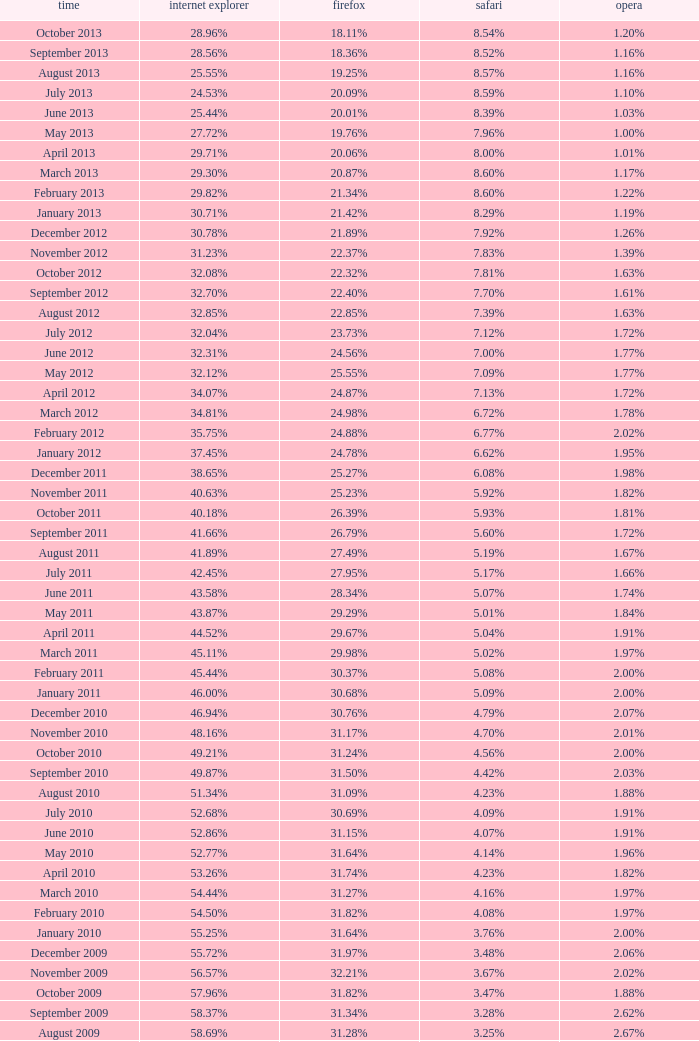Give me the full table as a dictionary. {'header': ['time', 'internet explorer', 'firefox', 'safari', 'opera'], 'rows': [['October 2013', '28.96%', '18.11%', '8.54%', '1.20%'], ['September 2013', '28.56%', '18.36%', '8.52%', '1.16%'], ['August 2013', '25.55%', '19.25%', '8.57%', '1.16%'], ['July 2013', '24.53%', '20.09%', '8.59%', '1.10%'], ['June 2013', '25.44%', '20.01%', '8.39%', '1.03%'], ['May 2013', '27.72%', '19.76%', '7.96%', '1.00%'], ['April 2013', '29.71%', '20.06%', '8.00%', '1.01%'], ['March 2013', '29.30%', '20.87%', '8.60%', '1.17%'], ['February 2013', '29.82%', '21.34%', '8.60%', '1.22%'], ['January 2013', '30.71%', '21.42%', '8.29%', '1.19%'], ['December 2012', '30.78%', '21.89%', '7.92%', '1.26%'], ['November 2012', '31.23%', '22.37%', '7.83%', '1.39%'], ['October 2012', '32.08%', '22.32%', '7.81%', '1.63%'], ['September 2012', '32.70%', '22.40%', '7.70%', '1.61%'], ['August 2012', '32.85%', '22.85%', '7.39%', '1.63%'], ['July 2012', '32.04%', '23.73%', '7.12%', '1.72%'], ['June 2012', '32.31%', '24.56%', '7.00%', '1.77%'], ['May 2012', '32.12%', '25.55%', '7.09%', '1.77%'], ['April 2012', '34.07%', '24.87%', '7.13%', '1.72%'], ['March 2012', '34.81%', '24.98%', '6.72%', '1.78%'], ['February 2012', '35.75%', '24.88%', '6.77%', '2.02%'], ['January 2012', '37.45%', '24.78%', '6.62%', '1.95%'], ['December 2011', '38.65%', '25.27%', '6.08%', '1.98%'], ['November 2011', '40.63%', '25.23%', '5.92%', '1.82%'], ['October 2011', '40.18%', '26.39%', '5.93%', '1.81%'], ['September 2011', '41.66%', '26.79%', '5.60%', '1.72%'], ['August 2011', '41.89%', '27.49%', '5.19%', '1.67%'], ['July 2011', '42.45%', '27.95%', '5.17%', '1.66%'], ['June 2011', '43.58%', '28.34%', '5.07%', '1.74%'], ['May 2011', '43.87%', '29.29%', '5.01%', '1.84%'], ['April 2011', '44.52%', '29.67%', '5.04%', '1.91%'], ['March 2011', '45.11%', '29.98%', '5.02%', '1.97%'], ['February 2011', '45.44%', '30.37%', '5.08%', '2.00%'], ['January 2011', '46.00%', '30.68%', '5.09%', '2.00%'], ['December 2010', '46.94%', '30.76%', '4.79%', '2.07%'], ['November 2010', '48.16%', '31.17%', '4.70%', '2.01%'], ['October 2010', '49.21%', '31.24%', '4.56%', '2.00%'], ['September 2010', '49.87%', '31.50%', '4.42%', '2.03%'], ['August 2010', '51.34%', '31.09%', '4.23%', '1.88%'], ['July 2010', '52.68%', '30.69%', '4.09%', '1.91%'], ['June 2010', '52.86%', '31.15%', '4.07%', '1.91%'], ['May 2010', '52.77%', '31.64%', '4.14%', '1.96%'], ['April 2010', '53.26%', '31.74%', '4.23%', '1.82%'], ['March 2010', '54.44%', '31.27%', '4.16%', '1.97%'], ['February 2010', '54.50%', '31.82%', '4.08%', '1.97%'], ['January 2010', '55.25%', '31.64%', '3.76%', '2.00%'], ['December 2009', '55.72%', '31.97%', '3.48%', '2.06%'], ['November 2009', '56.57%', '32.21%', '3.67%', '2.02%'], ['October 2009', '57.96%', '31.82%', '3.47%', '1.88%'], ['September 2009', '58.37%', '31.34%', '3.28%', '2.62%'], ['August 2009', '58.69%', '31.28%', '3.25%', '2.67%'], ['July 2009', '60.11%', '30.50%', '3.02%', '2.64%'], ['June 2009', '59.49%', '30.26%', '2.91%', '3.46%'], ['May 2009', '62.09%', '28.75%', '2.65%', '3.23%'], ['April 2009', '61.88%', '29.67%', '2.75%', '2.96%'], ['March 2009', '62.52%', '29.40%', '2.73%', '2.94%'], ['February 2009', '64.43%', '27.85%', '2.59%', '2.95%'], ['January 2009', '65.41%', '27.03%', '2.57%', '2.92%'], ['December 2008', '67.84%', '25.23%', '2.41%', '2.83%'], ['November 2008', '68.14%', '25.27%', '2.49%', '3.01%'], ['October 2008', '67.68%', '25.54%', '2.91%', '2.69%'], ['September2008', '67.16%', '25.77%', '3.00%', '2.86%'], ['August 2008', '68.91%', '26.08%', '2.99%', '1.83%'], ['July 2008', '68.57%', '26.14%', '3.30%', '1.78%']]} What percentage of browsers were using Opera in October 2010? 2.00%. 